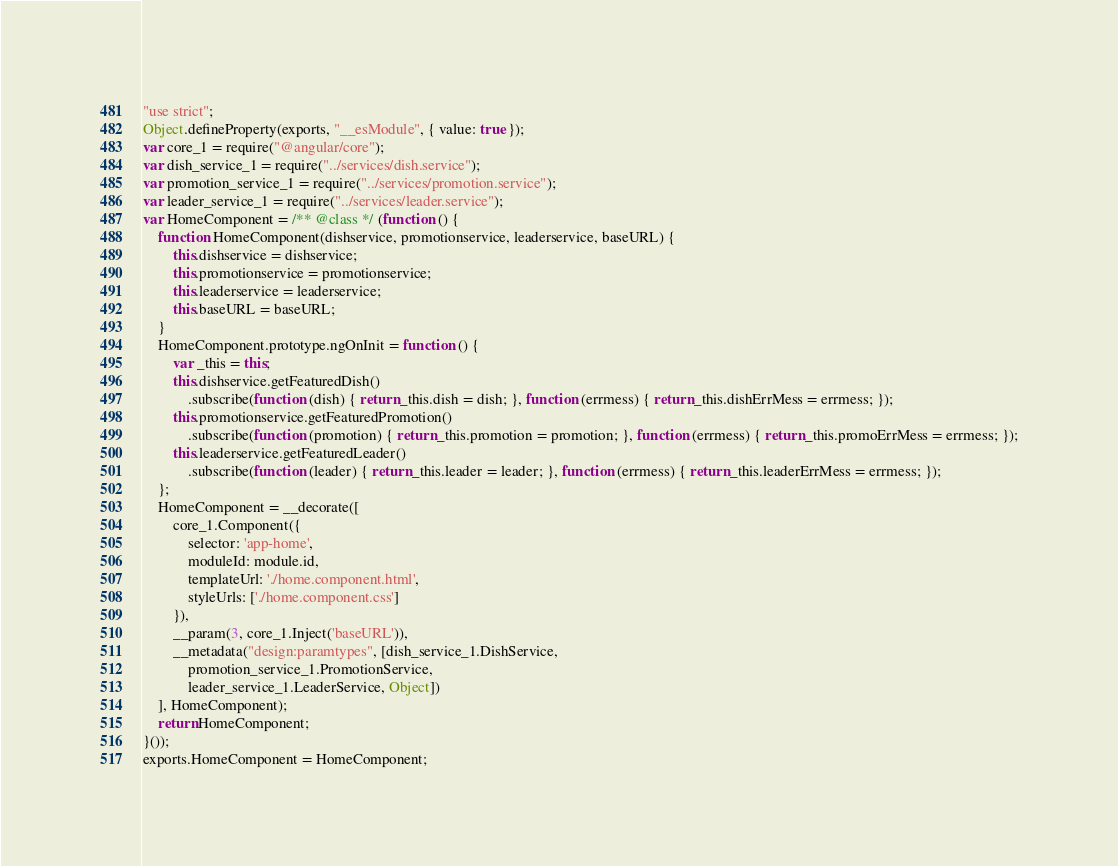Convert code to text. <code><loc_0><loc_0><loc_500><loc_500><_JavaScript_>"use strict";
Object.defineProperty(exports, "__esModule", { value: true });
var core_1 = require("@angular/core");
var dish_service_1 = require("../services/dish.service");
var promotion_service_1 = require("../services/promotion.service");
var leader_service_1 = require("../services/leader.service");
var HomeComponent = /** @class */ (function () {
    function HomeComponent(dishservice, promotionservice, leaderservice, baseURL) {
        this.dishservice = dishservice;
        this.promotionservice = promotionservice;
        this.leaderservice = leaderservice;
        this.baseURL = baseURL;
    }
    HomeComponent.prototype.ngOnInit = function () {
        var _this = this;
        this.dishservice.getFeaturedDish()
            .subscribe(function (dish) { return _this.dish = dish; }, function (errmess) { return _this.dishErrMess = errmess; });
        this.promotionservice.getFeaturedPromotion()
            .subscribe(function (promotion) { return _this.promotion = promotion; }, function (errmess) { return _this.promoErrMess = errmess; });
        this.leaderservice.getFeaturedLeader()
            .subscribe(function (leader) { return _this.leader = leader; }, function (errmess) { return _this.leaderErrMess = errmess; });
    };
    HomeComponent = __decorate([
        core_1.Component({
            selector: 'app-home',
            moduleId: module.id,
            templateUrl: './home.component.html',
            styleUrls: ['./home.component.css']
        }),
        __param(3, core_1.Inject('baseURL')),
        __metadata("design:paramtypes", [dish_service_1.DishService,
            promotion_service_1.PromotionService,
            leader_service_1.LeaderService, Object])
    ], HomeComponent);
    return HomeComponent;
}());
exports.HomeComponent = HomeComponent;</code> 